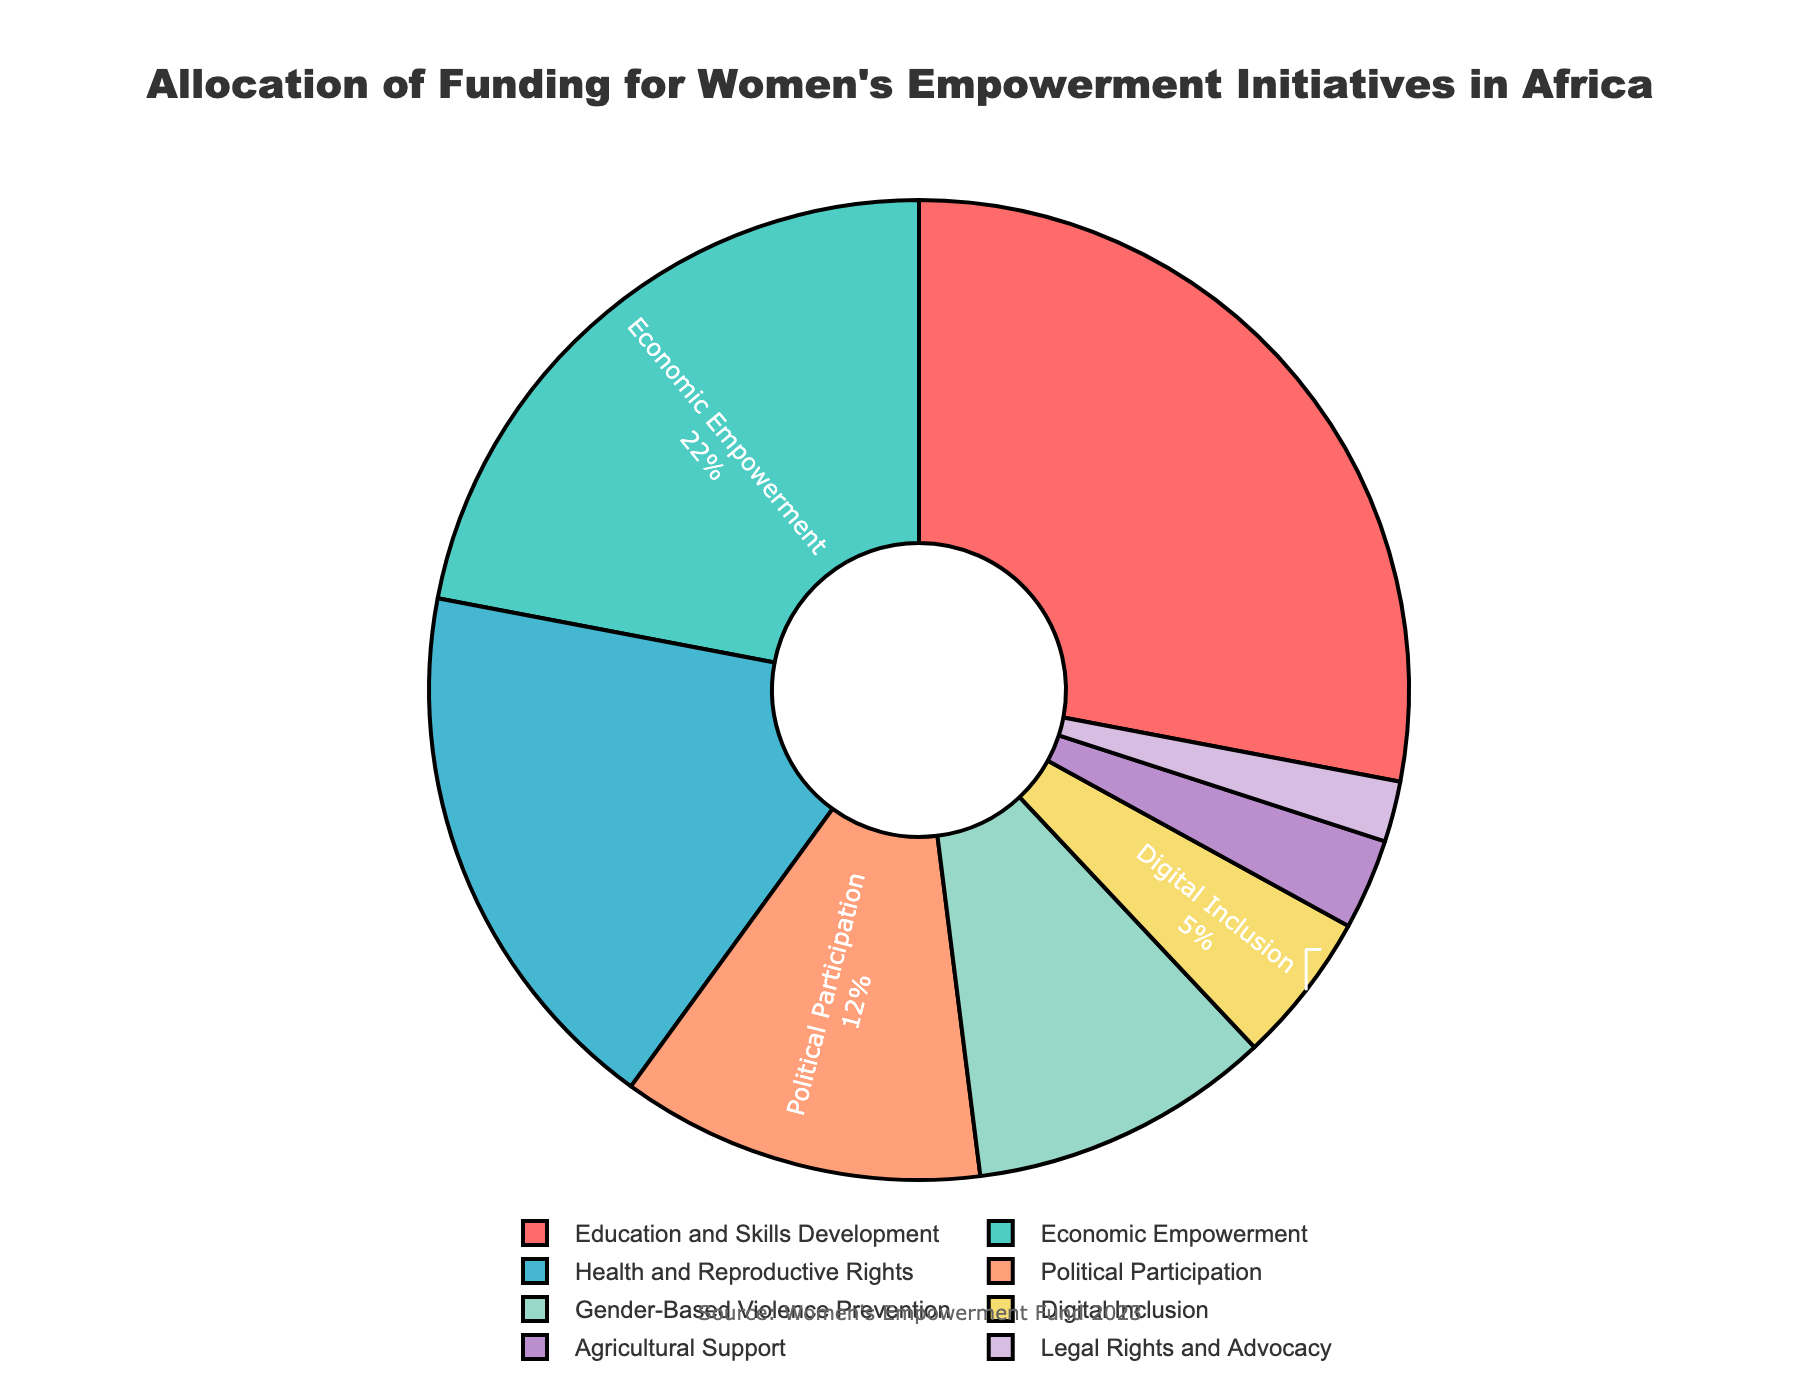What is the percentage of funding allocated to Digital Inclusion? The pie chart shows the allocation of funding by focus area, and we can directly see the percentage for Digital Inclusion.
Answer: 5% Which focus area receives more funding: Economic Empowerment or Health and Reproductive Rights? By looking at the pie chart, Economic Empowerment has a larger sector than Health and Reproductive Rights. Economic Empowerment receives 22% and Health and Reproductive Rights receive 18%.
Answer: Economic Empowerment What is the combined percentage of funding for Political Participation and Legal Rights and Advocacy? Sum the percentages allocated to Political Participation (12%) and Legal Rights and Advocacy (2%). 12% + 2% = 14%
Answer: 14% How much more funding is allocated to Education and Skills Development compared to Agricultural Support? Subtract the percentage for Agricultural Support (3%) from the percentage for Education and Skills Development (28%). 28% - 3% = 25%
Answer: 25% What percentage of funding is allocated to initiatives other than Education and Skills Development? Sum all percentages and subtract the percentage for Education and Skills Development (28%). 100% - 28% = 72%
Answer: 72% If funding for each focus area is cut by half, what would be the new percentage for Health and Reproductive Rights? Divide the current percentage for Health and Reproductive Rights (18%) by 2. 18% / 2 = 9%
Answer: 9% Compare the percentage of funding for Gender-Based Violence Prevention and Political Participation. How much greater is one than the other? Subtract the percentage for Political Participation (12%) from the percentage for Gender-Based Violence Prevention (10%). 12% - 10% = 2%
Answer: 2% What is the visual representation color of the Agricultural Support sector? By looking at the color-coded pie chart, identify the color for the Agricultural Support sector (3%).
Answer: Light purple If Digital Inclusion and Health and Reproductive Rights receive equal funding, what would be their new combined percentage? Find the new combined percentage by summing their current percentages (Digital Inclusion 5% and Health and Reproductive Rights 18%) and then divide by 2. (5% + 18%) / 2 = 11.5%. Since two areas are merged, the final percentage should be doubled: 2 * 11.5% = 23%
Answer: 23% 